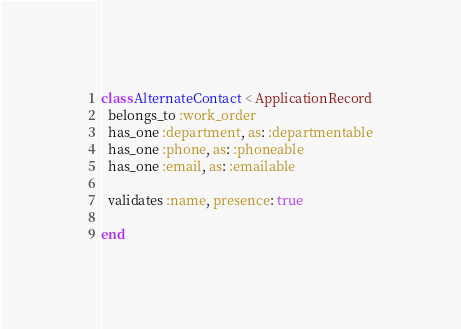<code> <loc_0><loc_0><loc_500><loc_500><_Ruby_>class AlternateContact < ApplicationRecord
  belongs_to :work_order
  has_one :department, as: :departmentable
  has_one :phone, as: :phoneable
  has_one :email, as: :emailable

  validates :name, presence: true
  
end
</code> 